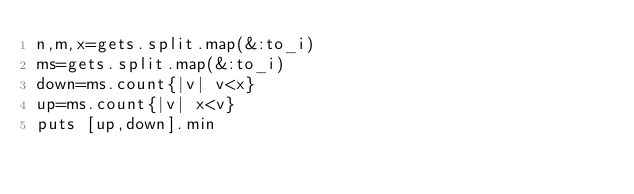Convert code to text. <code><loc_0><loc_0><loc_500><loc_500><_Ruby_>n,m,x=gets.split.map(&:to_i)
ms=gets.split.map(&:to_i)
down=ms.count{|v| v<x}
up=ms.count{|v| x<v}
puts [up,down].min
</code> 